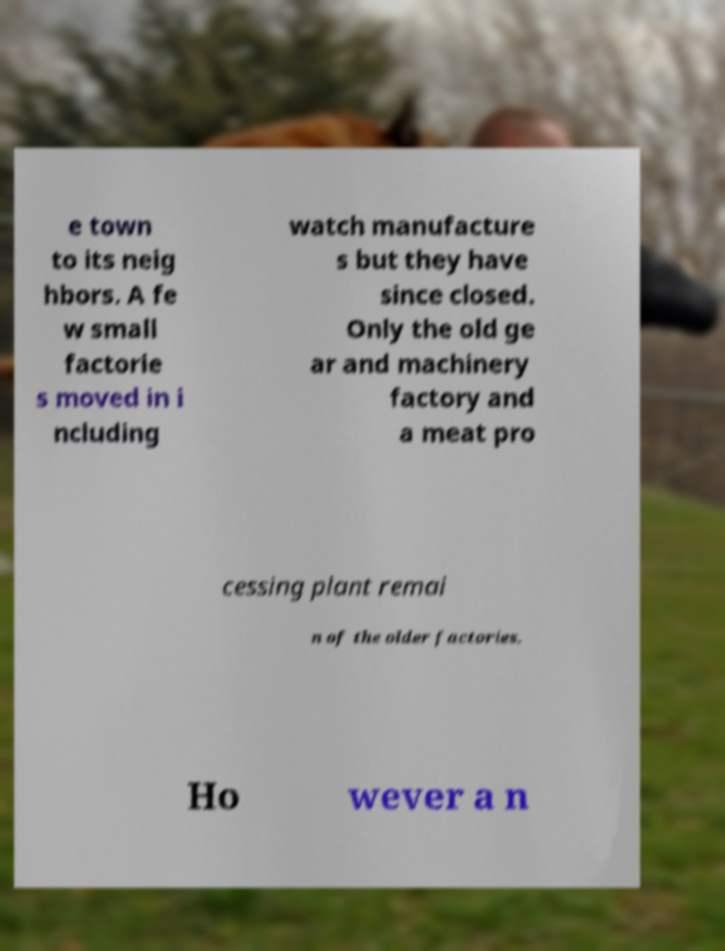Could you assist in decoding the text presented in this image and type it out clearly? e town to its neig hbors. A fe w small factorie s moved in i ncluding watch manufacture s but they have since closed. Only the old ge ar and machinery factory and a meat pro cessing plant remai n of the older factories. Ho wever a n 